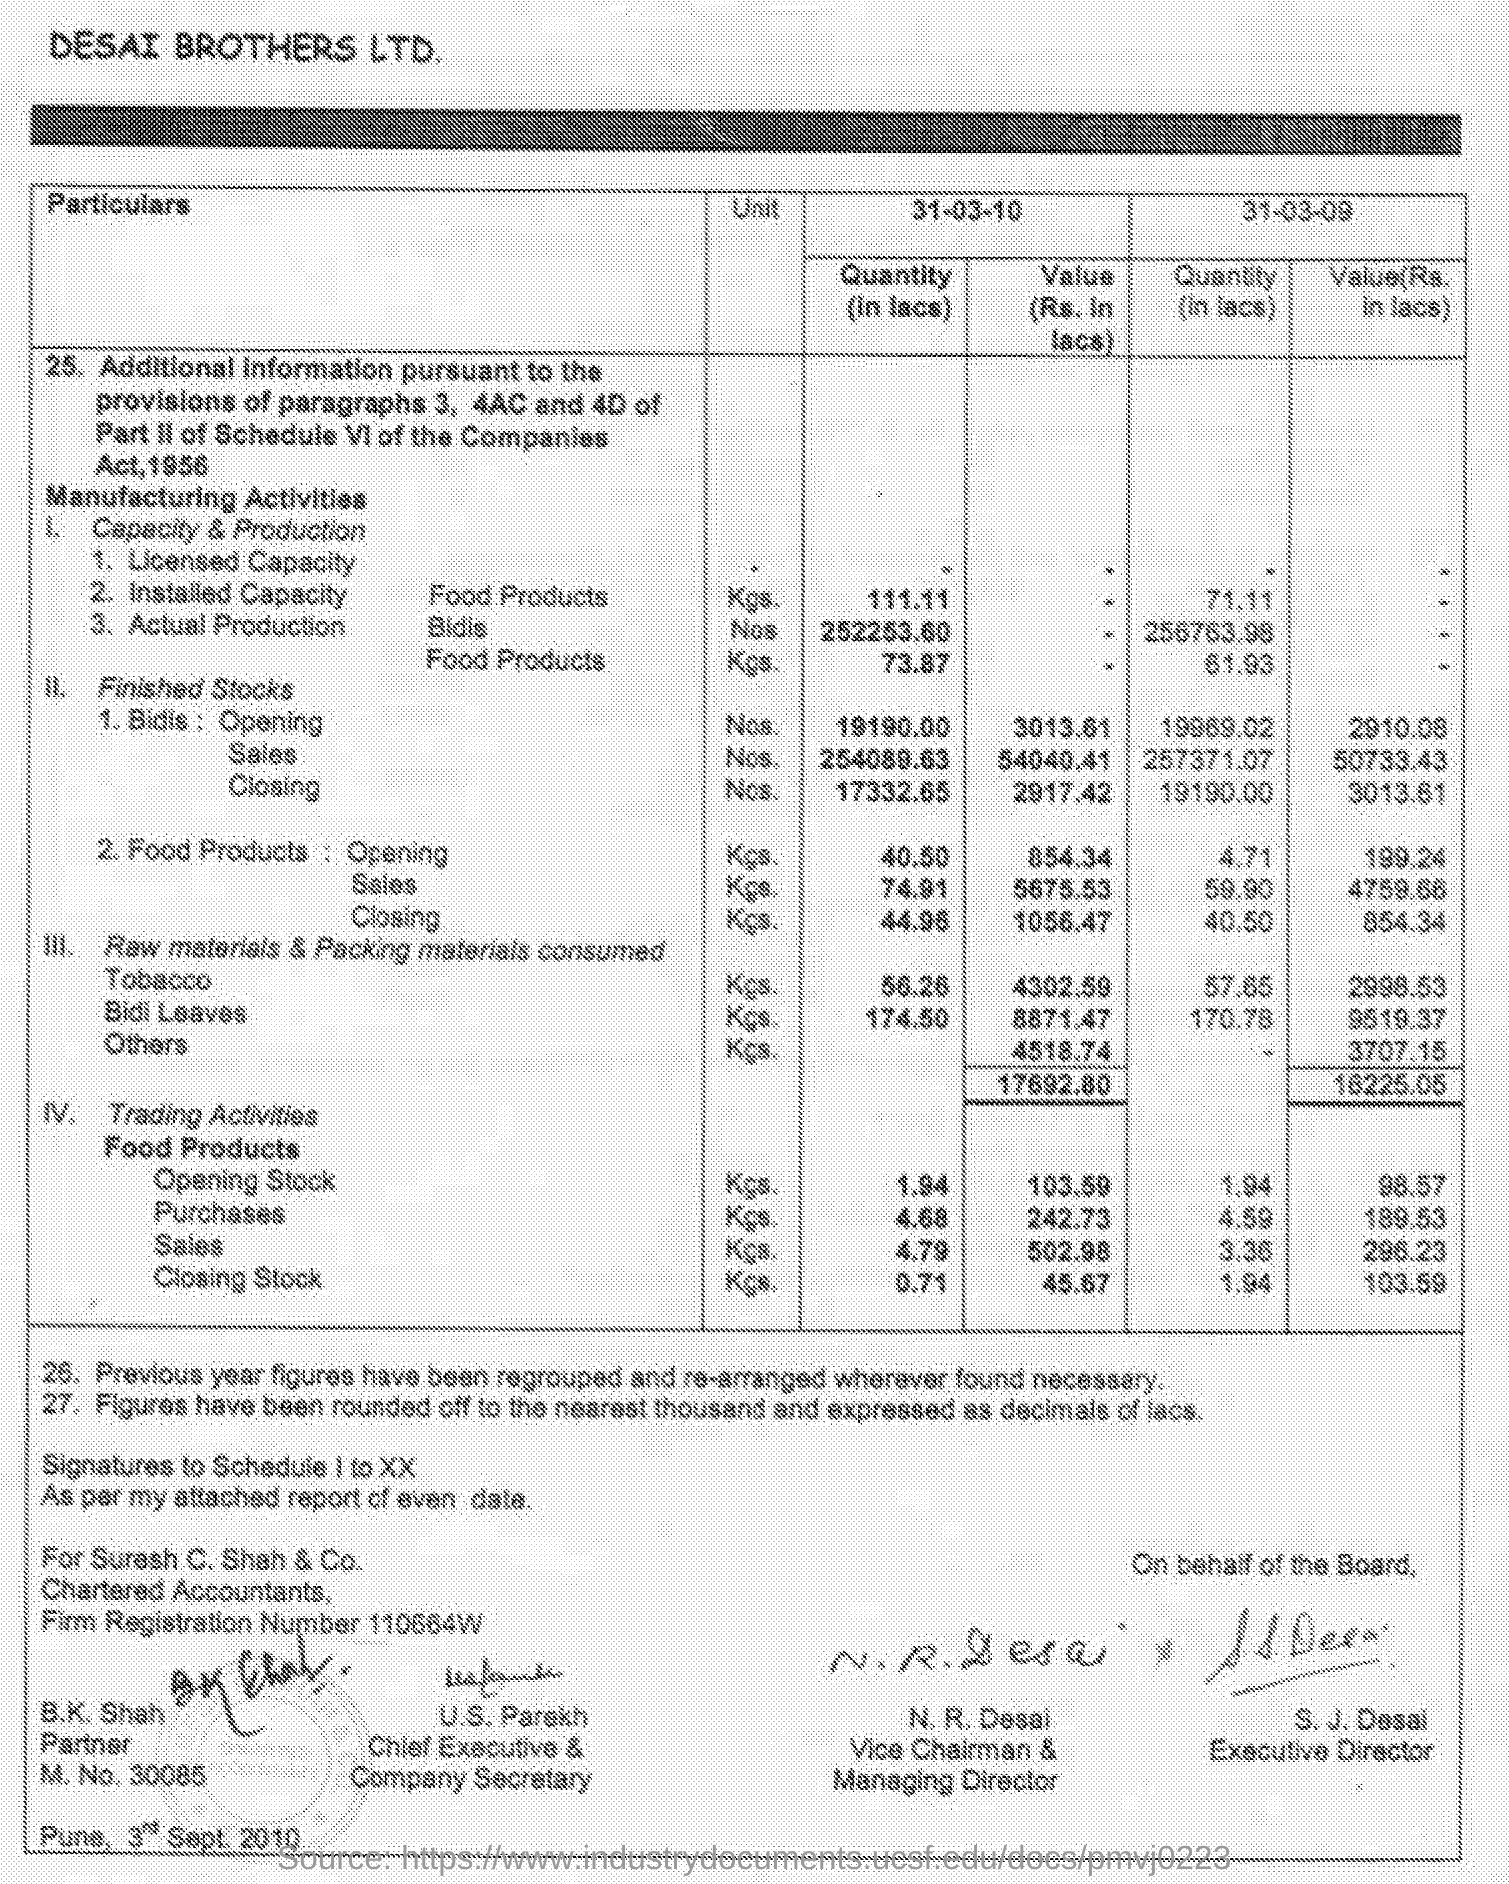What is the heading?
Your answer should be very brief. DESAI BROTHERS LTD. What is the heading given to the first column of the table?
Offer a very short reply. Particulars. Food products are mentioned in which unit?
Your answer should be very brief. Kgs. What is the designation of "S.J. Desai"?
Your answer should be very brief. Executive director. What is the designation of "N.R. Desai"?
Offer a very short reply. Vice chairman & managing director. What is the designation of "U.S. Parekh"?
Give a very brief answer. Chief Executive & Company Secretary. Who is B.K. Shah?
Give a very brief answer. Partner. Mention name of the city given at the bottom left corner of the page?
Offer a terse response. Pune. Mention "M.NO." given?
Make the answer very short. 30085. 